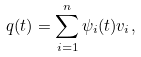<formula> <loc_0><loc_0><loc_500><loc_500>q ( t ) = \sum _ { i = 1 } ^ { n } \psi _ { i } ( t ) v _ { i } ,</formula> 